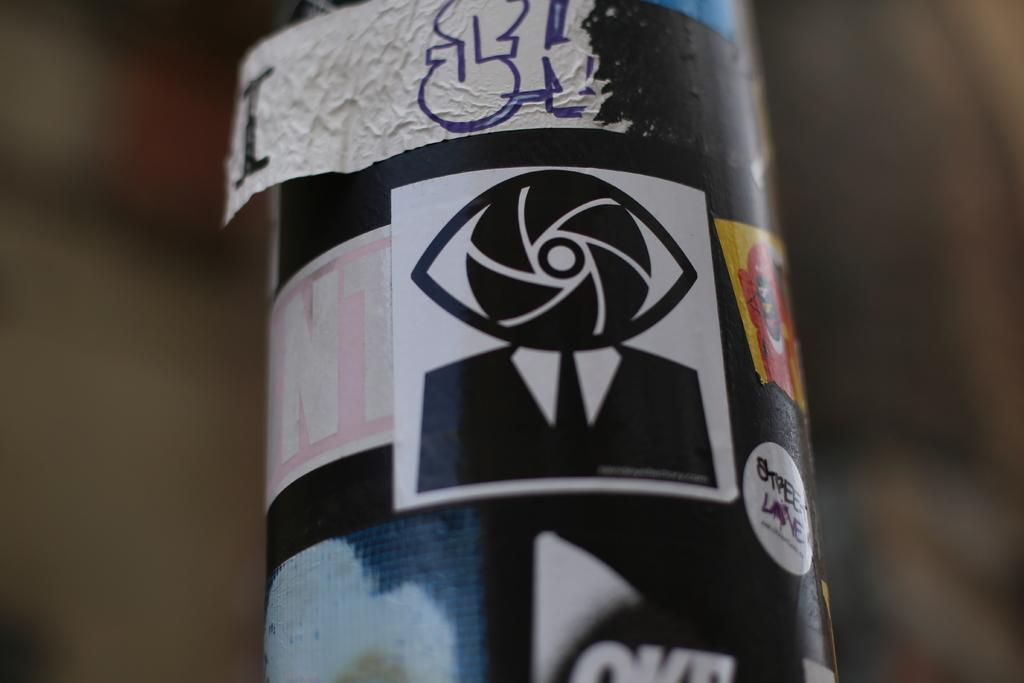What is the main object in the image? There is a pole in the image. Are there any additional features on the pole? Yes, there are stickers on the pole. What grade is the student playing with the coil in the image? There is no student, coil, or play activity present in the image; it only features a pole with stickers on it. 